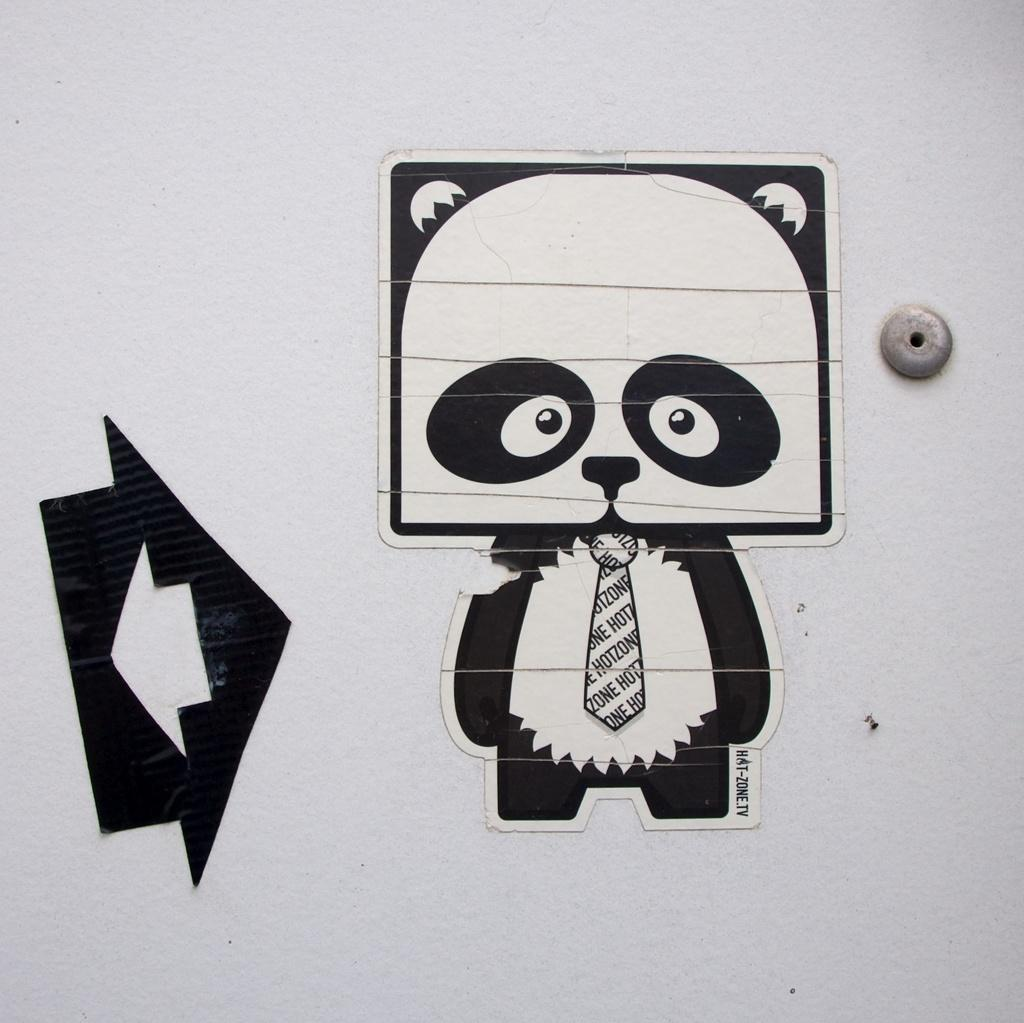What can be seen in the background of the image? There is a wall in the image. What is on the wall? There are objects on the wall. Can you see a mountain in the image? There is no mountain visible in the image; it only features a wall with objects on it. Is there a kitty playing with the objects on the wall in the image? There is no kitty present in the image. 